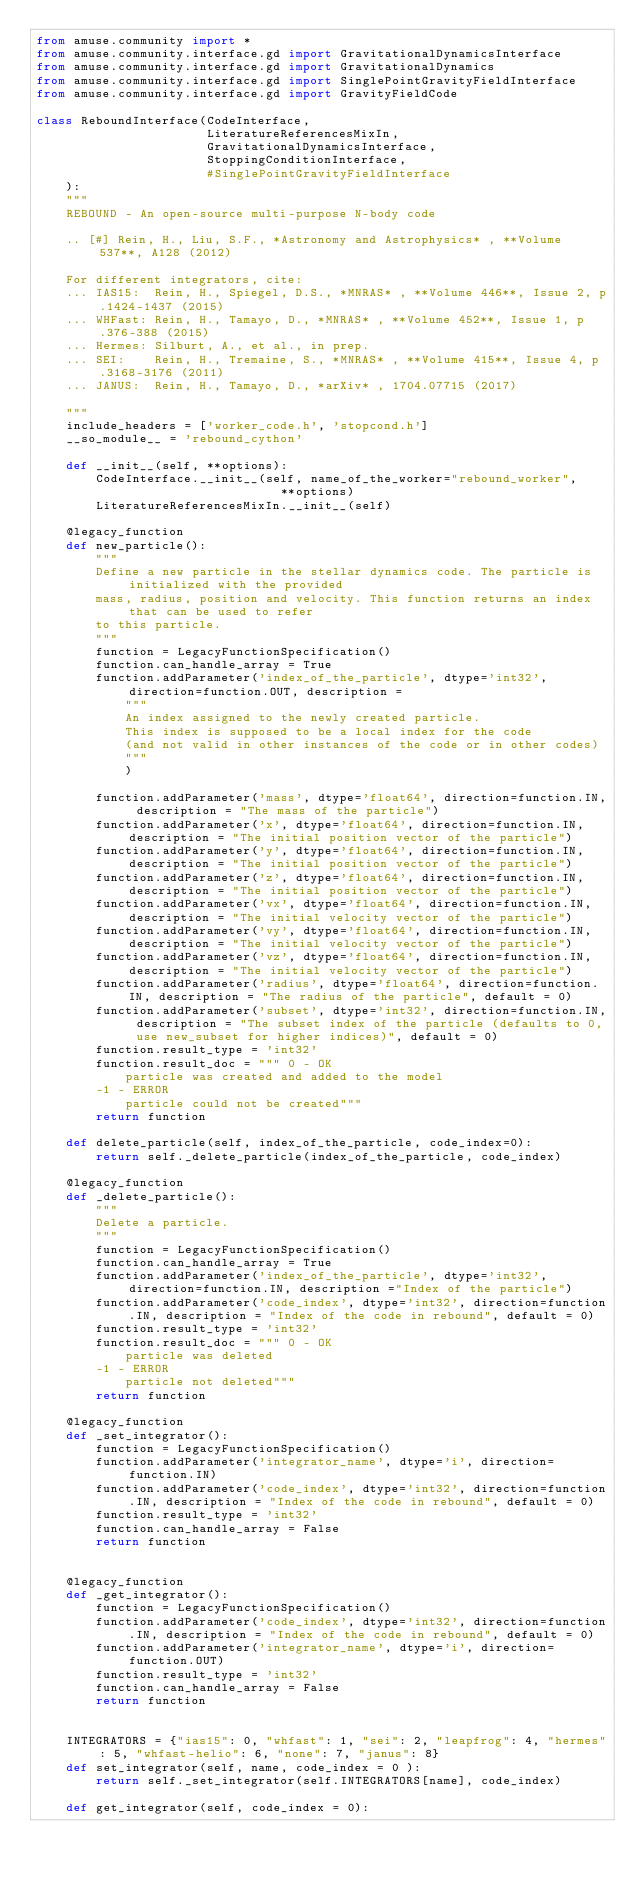<code> <loc_0><loc_0><loc_500><loc_500><_Python_>from amuse.community import *
from amuse.community.interface.gd import GravitationalDynamicsInterface
from amuse.community.interface.gd import GravitationalDynamics
from amuse.community.interface.gd import SinglePointGravityFieldInterface
from amuse.community.interface.gd import GravityFieldCode

class ReboundInterface(CodeInterface,
                       LiteratureReferencesMixIn,
                       GravitationalDynamicsInterface,
                       StoppingConditionInterface,
                       #SinglePointGravityFieldInterface
    ):
    """
    REBOUND - An open-source multi-purpose N-body code
    
    .. [#] Rein, H., Liu, S.F., *Astronomy and Astrophysics* , **Volume 537**, A128 (2012)
    
    For different integrators, cite:
    ... IAS15:  Rein, H., Spiegel, D.S., *MNRAS* , **Volume 446**, Issue 2, p.1424-1437 (2015)
    ... WHFast: Rein, H., Tamayo, D., *MNRAS* , **Volume 452**, Issue 1, p.376-388 (2015)
    ... Hermes: Silburt, A., et al., in prep.
    ... SEI:    Rein, H., Tremaine, S., *MNRAS* , **Volume 415**, Issue 4, p.3168-3176 (2011)
    ... JANUS:  Rein, H., Tamayo, D., *arXiv* , 1704.07715 (2017)
        
    """
    include_headers = ['worker_code.h', 'stopcond.h']
    __so_module__ = 'rebound_cython'

    def __init__(self, **options):
        CodeInterface.__init__(self, name_of_the_worker="rebound_worker",
                                 **options)
        LiteratureReferencesMixIn.__init__(self)
        
    @legacy_function
    def new_particle():
        """
        Define a new particle in the stellar dynamics code. The particle is initialized with the provided
        mass, radius, position and velocity. This function returns an index that can be used to refer
        to this particle.
        """
        function = LegacyFunctionSpecification()
        function.can_handle_array = True
        function.addParameter('index_of_the_particle', dtype='int32', direction=function.OUT, description =
            """
            An index assigned to the newly created particle.
            This index is supposed to be a local index for the code
            (and not valid in other instances of the code or in other codes)
            """
            )

        function.addParameter('mass', dtype='float64', direction=function.IN, description = "The mass of the particle")
        function.addParameter('x', dtype='float64', direction=function.IN, description = "The initial position vector of the particle")
        function.addParameter('y', dtype='float64', direction=function.IN, description = "The initial position vector of the particle")
        function.addParameter('z', dtype='float64', direction=function.IN, description = "The initial position vector of the particle")
        function.addParameter('vx', dtype='float64', direction=function.IN, description = "The initial velocity vector of the particle")
        function.addParameter('vy', dtype='float64', direction=function.IN, description = "The initial velocity vector of the particle")
        function.addParameter('vz', dtype='float64', direction=function.IN, description = "The initial velocity vector of the particle")
        function.addParameter('radius', dtype='float64', direction=function.IN, description = "The radius of the particle", default = 0)
        function.addParameter('subset', dtype='int32', direction=function.IN, description = "The subset index of the particle (defaults to 0, use new_subset for higher indices)", default = 0)
        function.result_type = 'int32'
        function.result_doc = """ 0 - OK
            particle was created and added to the model
        -1 - ERROR
            particle could not be created"""
        return function
        
    def delete_particle(self, index_of_the_particle, code_index=0):
        return self._delete_particle(index_of_the_particle, code_index)

    @legacy_function
    def _delete_particle():
        """
        Delete a particle.
        """
        function = LegacyFunctionSpecification()
        function.can_handle_array = True
        function.addParameter('index_of_the_particle', dtype='int32', direction=function.IN, description ="Index of the particle")
        function.addParameter('code_index', dtype='int32', direction=function.IN, description = "Index of the code in rebound", default = 0)
        function.result_type = 'int32'
        function.result_doc = """ 0 - OK
            particle was deleted
        -1 - ERROR
            particle not deleted"""
        return function

    @legacy_function
    def _set_integrator():
        function = LegacyFunctionSpecification()      
        function.addParameter('integrator_name', dtype='i', direction=function.IN)
        function.addParameter('code_index', dtype='int32', direction=function.IN, description = "Index of the code in rebound", default = 0)
        function.result_type = 'int32'
        function.can_handle_array = False
        return function  
        

    @legacy_function
    def _get_integrator():
        function = LegacyFunctionSpecification()      
        function.addParameter('code_index', dtype='int32', direction=function.IN, description = "Index of the code in rebound", default = 0)
        function.addParameter('integrator_name', dtype='i', direction=function.OUT)
        function.result_type = 'int32'
        function.can_handle_array = False
        return function  
    

    INTEGRATORS = {"ias15": 0, "whfast": 1, "sei": 2, "leapfrog": 4, "hermes": 5, "whfast-helio": 6, "none": 7, "janus": 8}
    def set_integrator(self, name, code_index = 0 ):
        return self._set_integrator(self.INTEGRATORS[name], code_index)
    
    def get_integrator(self, code_index = 0):</code> 